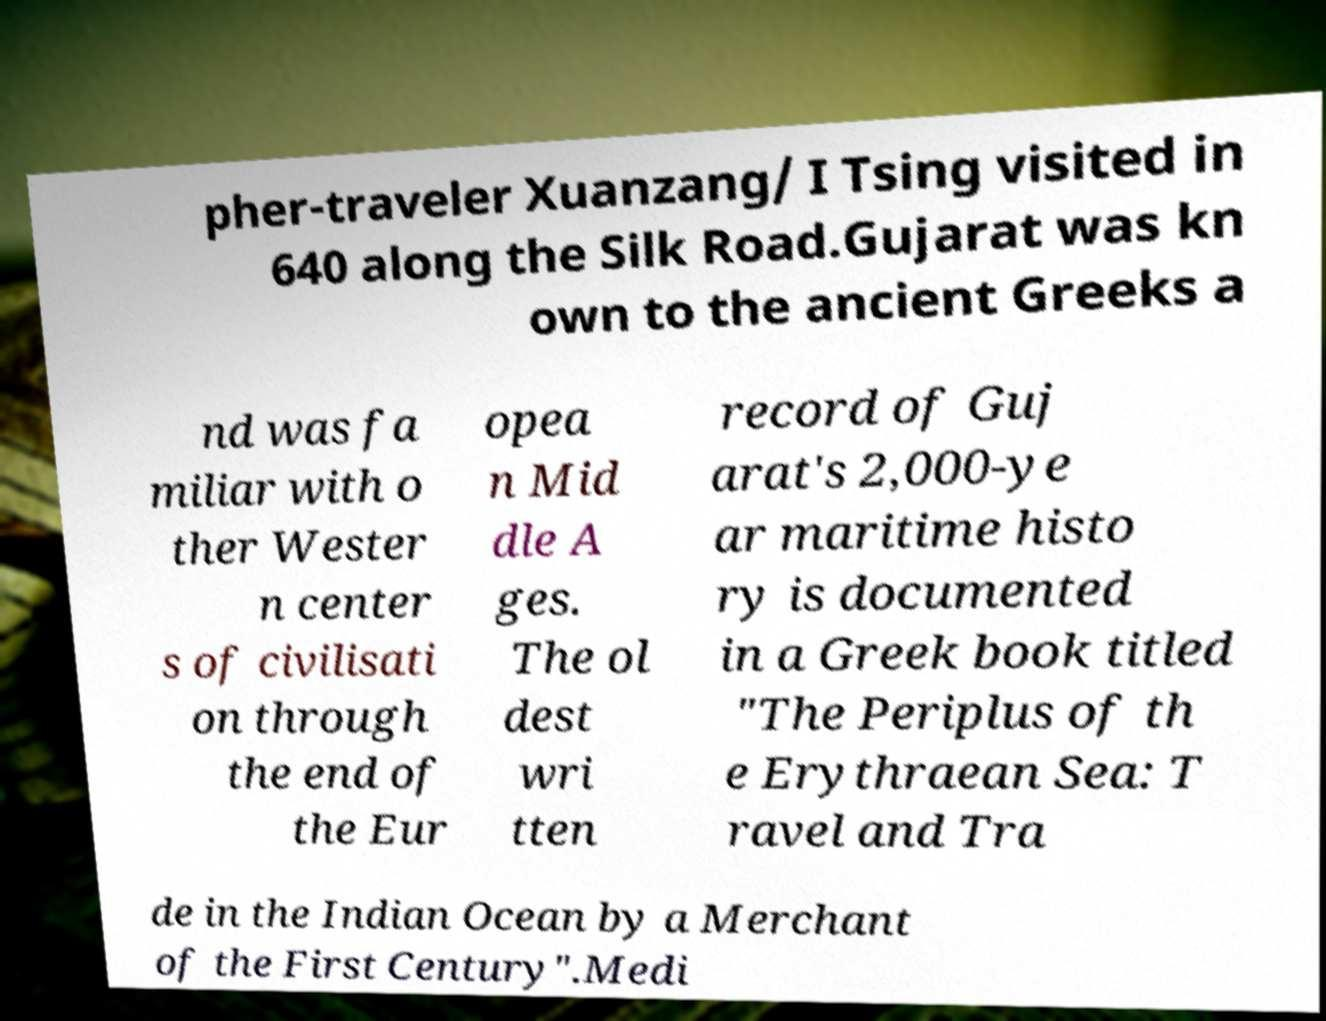Please read and relay the text visible in this image. What does it say? pher-traveler Xuanzang/ I Tsing visited in 640 along the Silk Road.Gujarat was kn own to the ancient Greeks a nd was fa miliar with o ther Wester n center s of civilisati on through the end of the Eur opea n Mid dle A ges. The ol dest wri tten record of Guj arat's 2,000-ye ar maritime histo ry is documented in a Greek book titled "The Periplus of th e Erythraean Sea: T ravel and Tra de in the Indian Ocean by a Merchant of the First Century".Medi 